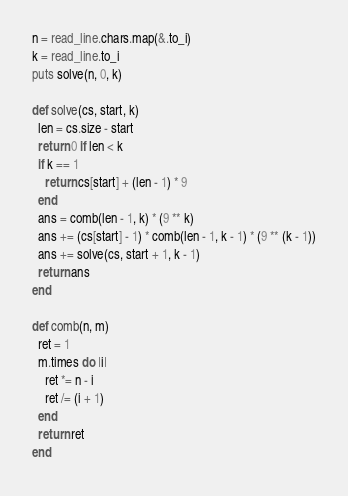<code> <loc_0><loc_0><loc_500><loc_500><_Crystal_>n = read_line.chars.map(&.to_i)
k = read_line.to_i
puts solve(n, 0, k)

def solve(cs, start, k)
  len = cs.size - start
  return 0 if len < k
  if k == 1
    return cs[start] + (len - 1) * 9
  end
  ans = comb(len - 1, k) * (9 ** k)
  ans += (cs[start] - 1) * comb(len - 1, k - 1) * (9 ** (k - 1))
  ans += solve(cs, start + 1, k - 1)
  return ans
end

def comb(n, m)
  ret = 1
  m.times do |i|
    ret *= n - i
    ret /= (i + 1)
  end
  return ret
end
</code> 